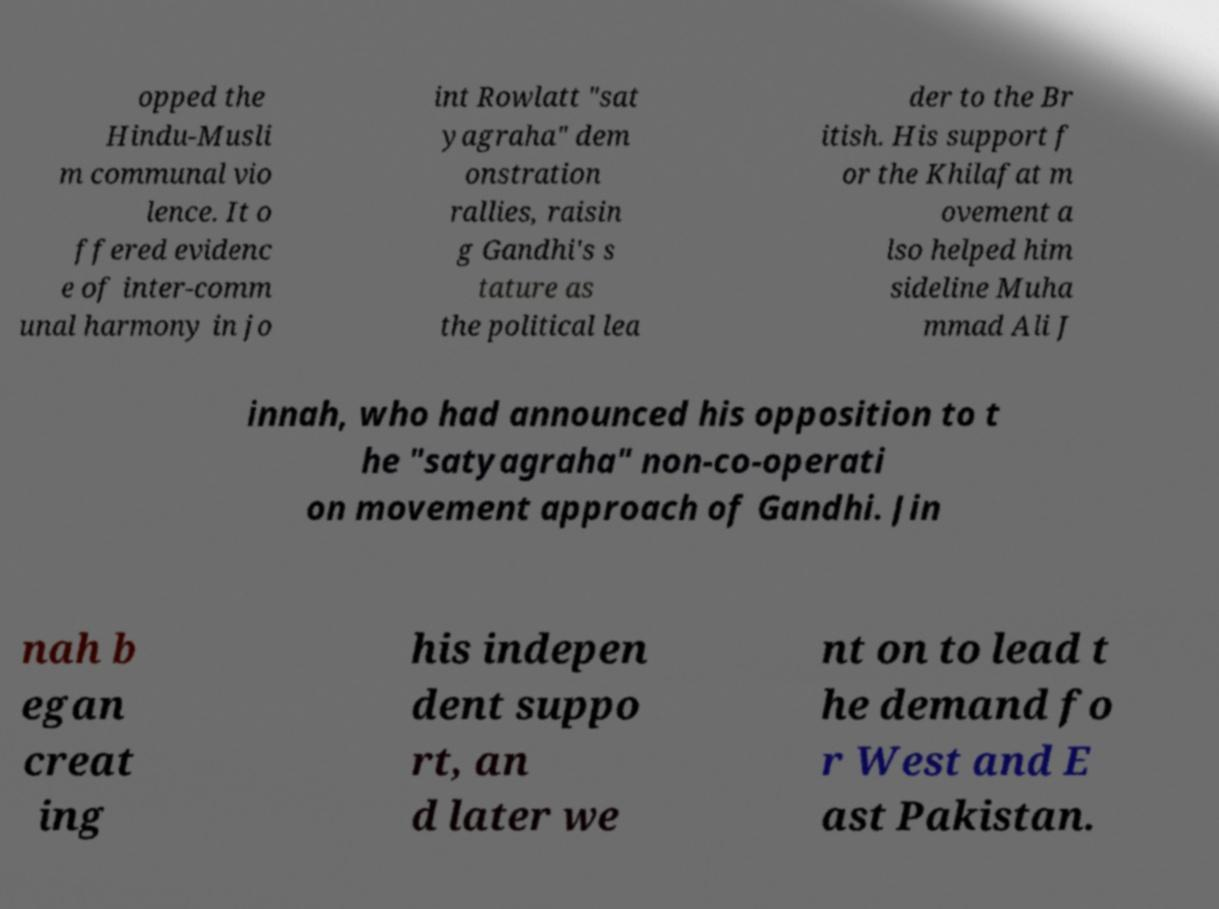I need the written content from this picture converted into text. Can you do that? opped the Hindu-Musli m communal vio lence. It o ffered evidenc e of inter-comm unal harmony in jo int Rowlatt "sat yagraha" dem onstration rallies, raisin g Gandhi's s tature as the political lea der to the Br itish. His support f or the Khilafat m ovement a lso helped him sideline Muha mmad Ali J innah, who had announced his opposition to t he "satyagraha" non-co-operati on movement approach of Gandhi. Jin nah b egan creat ing his indepen dent suppo rt, an d later we nt on to lead t he demand fo r West and E ast Pakistan. 